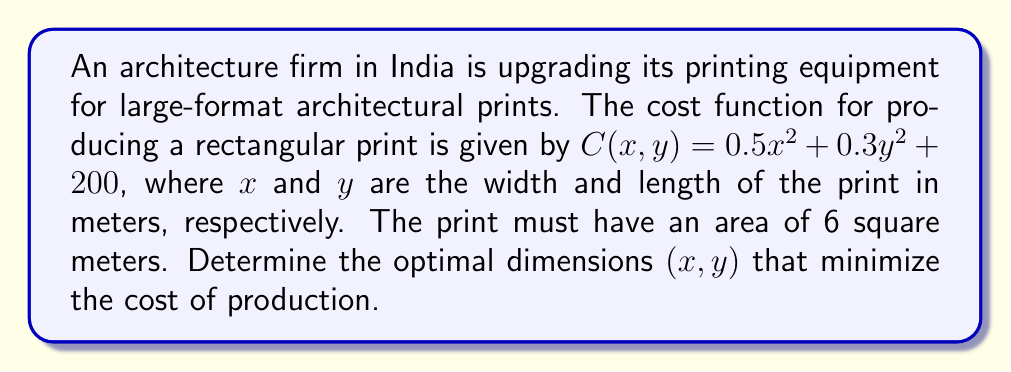Teach me how to tackle this problem. 1) First, we need to set up the constraint equation for the area:
   $xy = 6$

2) We can express $y$ in terms of $x$:
   $y = \frac{6}{x}$

3) Substitute this into the cost function:
   $C(x) = 0.5x^2 + 0.3(\frac{6}{x})^2 + 200$

4) To find the minimum cost, we need to find where the derivative of $C(x)$ equals zero:
   $\frac{dC}{dx} = x - \frac{21.6}{x^3} = 0$

5) Multiply both sides by $x^3$:
   $x^4 = 21.6$

6) Solve for $x$:
   $x = \sqrt[4]{21.6} \approx 2.138$ meters

7) Calculate $y$ using the constraint equation:
   $y = \frac{6}{x} \approx 2.807$ meters

8) Verify that this is a minimum by checking the second derivative:
   $\frac{d^2C}{dx^2} = 1 + \frac{64.8}{x^4} > 0$ for all $x > 0$, confirming a minimum.
Answer: $(x,y) \approx (2.138, 2.807)$ meters 